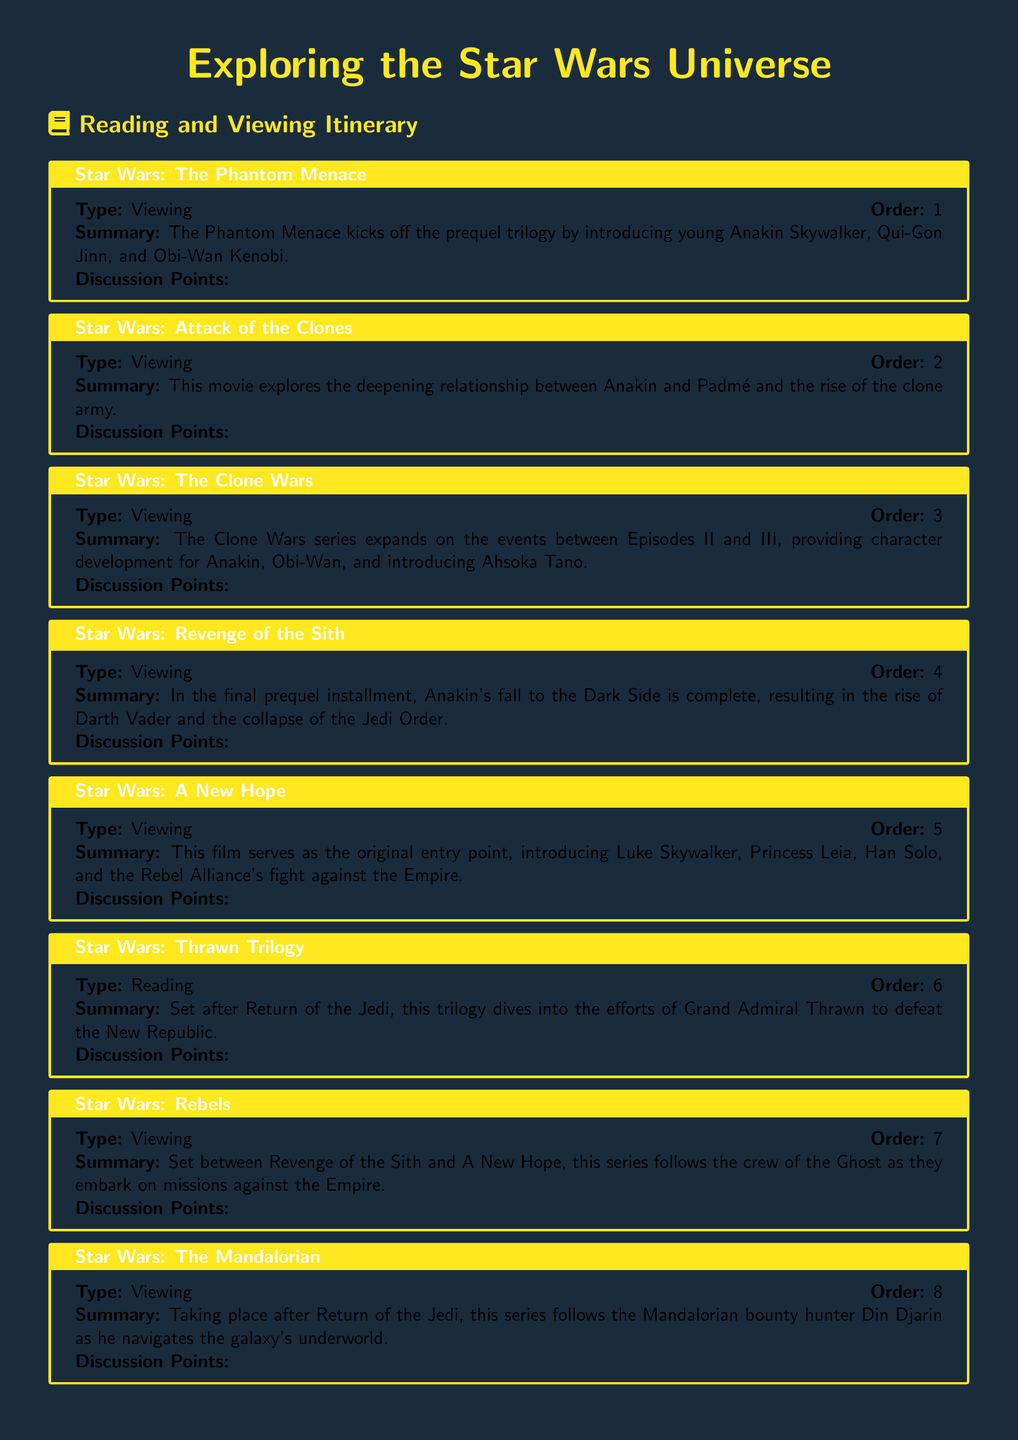What is the title of the itinerary? The title of the itinerary is presented in a prominent manner at the top of the document.
Answer: Exploring the Star Wars Universe How many viewing entries are listed? The document includes individual entries, some of which are designated as viewing.
Answer: 8 What is the order of "Star Wars: The Clone Wars"? Each entry is numbered sequentially, and the order is indicated within each box.
Answer: 3 Who is introduced in "Star Wars: The Phantom Menace"? The summary of the entry mentions key characters that are introduced in this film.
Answer: Anakin Skywalker, Qui-Gon Jinn, Obi-Wan Kenobi What type of media is "Star Wars: Thrawn Trilogy"? The document specifies the type of each entry clearly.
Answer: Reading What character development is highlighted in "Star Wars: The Clone Wars"? The summary discusses character development featured in the entry, regarding key relationships.
Answer: Anakin, Obi-Wan, Ahsoka Tano Which series takes place after "Return of the Jedi"? The sequence of entries indicates the timeline of the media.
Answer: The Mandalorian What is the focus of "Star Wars: Heir to the Jedi"? The summary provides insights into the thematic focus of the entry regarding character growth.
Answer: Luke Skywalker's growth as a Jedi How many total entries are included in the itinerary? The document includes both viewing and reading entries, and they can be counted.
Answer: 9 